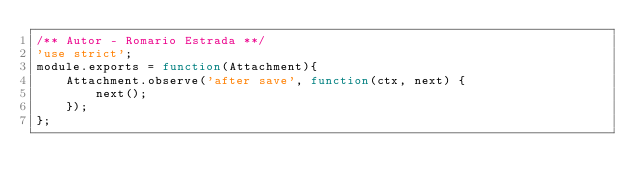<code> <loc_0><loc_0><loc_500><loc_500><_JavaScript_>/** Autor - Romario Estrada **/
'use strict';
module.exports = function(Attachment){
    Attachment.observe('after save', function(ctx, next) {
        next();
    });
};</code> 